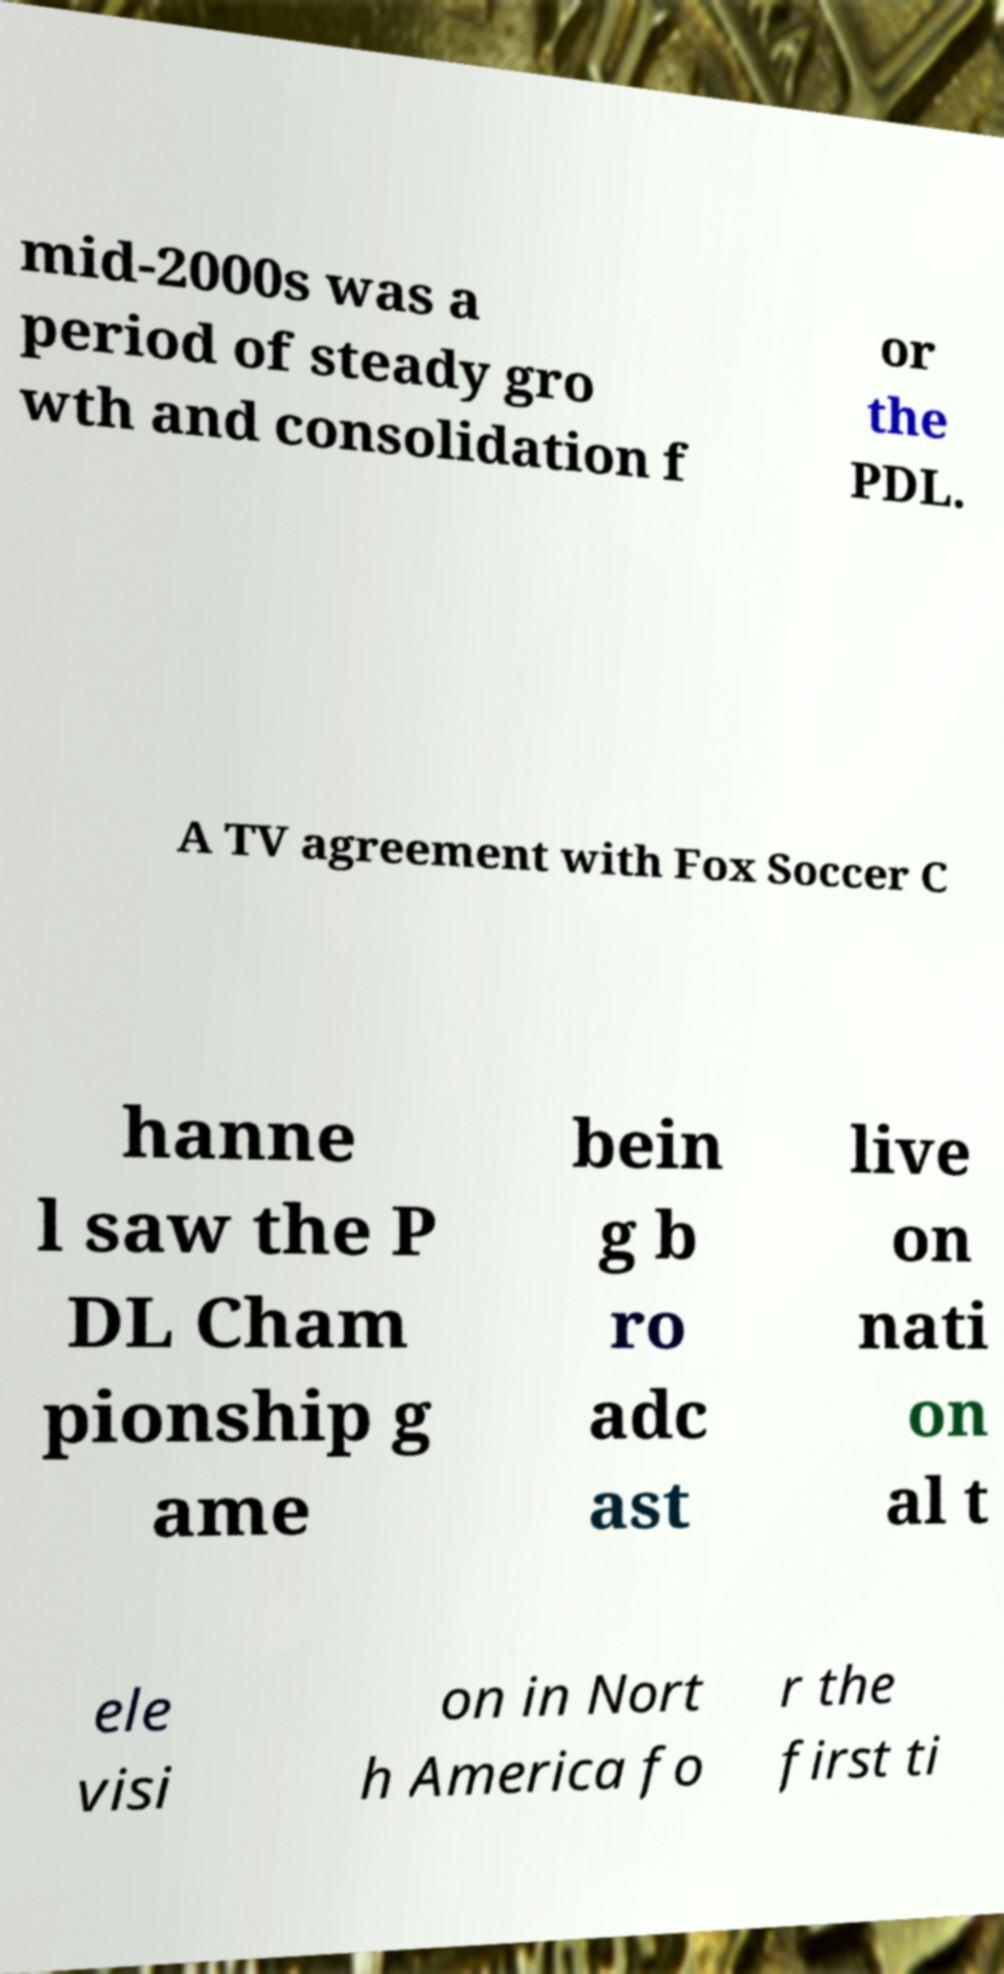There's text embedded in this image that I need extracted. Can you transcribe it verbatim? mid-2000s was a period of steady gro wth and consolidation f or the PDL. A TV agreement with Fox Soccer C hanne l saw the P DL Cham pionship g ame bein g b ro adc ast live on nati on al t ele visi on in Nort h America fo r the first ti 